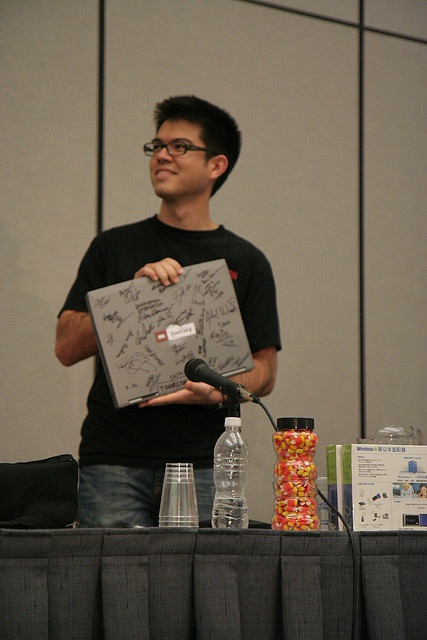Describe the objects in this image and their specific colors. I can see people in gray and black tones, laptop in gray and black tones, bottle in gray, brown, and black tones, bottle in gray and darkgray tones, and cup in gray and darkgray tones in this image. 